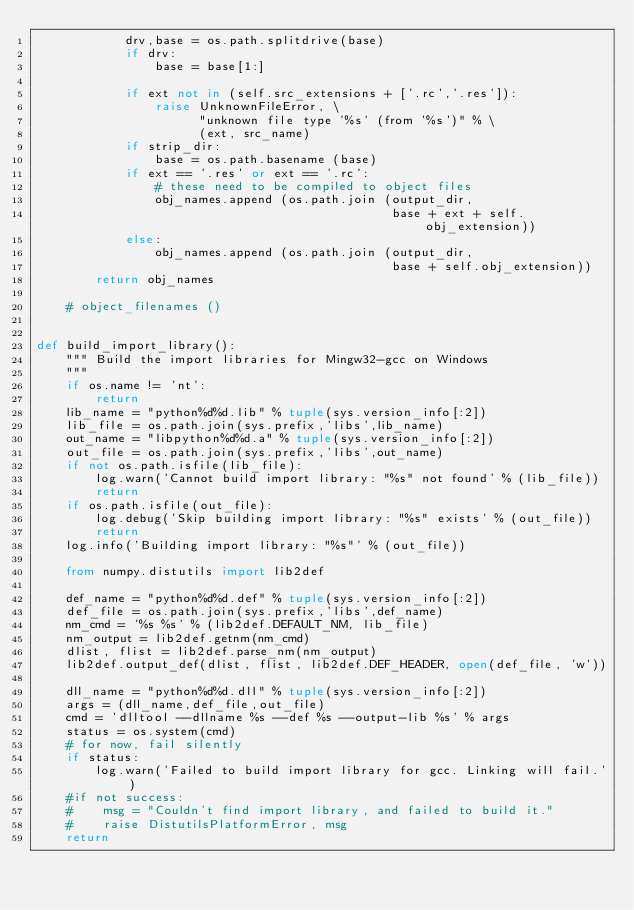<code> <loc_0><loc_0><loc_500><loc_500><_Python_>            drv,base = os.path.splitdrive(base)
            if drv:
                base = base[1:]

            if ext not in (self.src_extensions + ['.rc','.res']):
                raise UnknownFileError, \
                      "unknown file type '%s' (from '%s')" % \
                      (ext, src_name)
            if strip_dir:
                base = os.path.basename (base)
            if ext == '.res' or ext == '.rc':
                # these need to be compiled to object files
                obj_names.append (os.path.join (output_dir,
                                                base + ext + self.obj_extension))
            else:
                obj_names.append (os.path.join (output_dir,
                                                base + self.obj_extension))
        return obj_names

    # object_filenames ()


def build_import_library():
    """ Build the import libraries for Mingw32-gcc on Windows
    """
    if os.name != 'nt':
        return
    lib_name = "python%d%d.lib" % tuple(sys.version_info[:2])
    lib_file = os.path.join(sys.prefix,'libs',lib_name)
    out_name = "libpython%d%d.a" % tuple(sys.version_info[:2])
    out_file = os.path.join(sys.prefix,'libs',out_name)
    if not os.path.isfile(lib_file):
        log.warn('Cannot build import library: "%s" not found' % (lib_file))
        return
    if os.path.isfile(out_file):
        log.debug('Skip building import library: "%s" exists' % (out_file))
        return
    log.info('Building import library: "%s"' % (out_file))

    from numpy.distutils import lib2def

    def_name = "python%d%d.def" % tuple(sys.version_info[:2])
    def_file = os.path.join(sys.prefix,'libs',def_name)
    nm_cmd = '%s %s' % (lib2def.DEFAULT_NM, lib_file)
    nm_output = lib2def.getnm(nm_cmd)
    dlist, flist = lib2def.parse_nm(nm_output)
    lib2def.output_def(dlist, flist, lib2def.DEF_HEADER, open(def_file, 'w'))

    dll_name = "python%d%d.dll" % tuple(sys.version_info[:2])
    args = (dll_name,def_file,out_file)
    cmd = 'dlltool --dllname %s --def %s --output-lib %s' % args
    status = os.system(cmd)
    # for now, fail silently
    if status:
        log.warn('Failed to build import library for gcc. Linking will fail.')
    #if not success:
    #    msg = "Couldn't find import library, and failed to build it."
    #    raise DistutilsPlatformError, msg
    return
</code> 